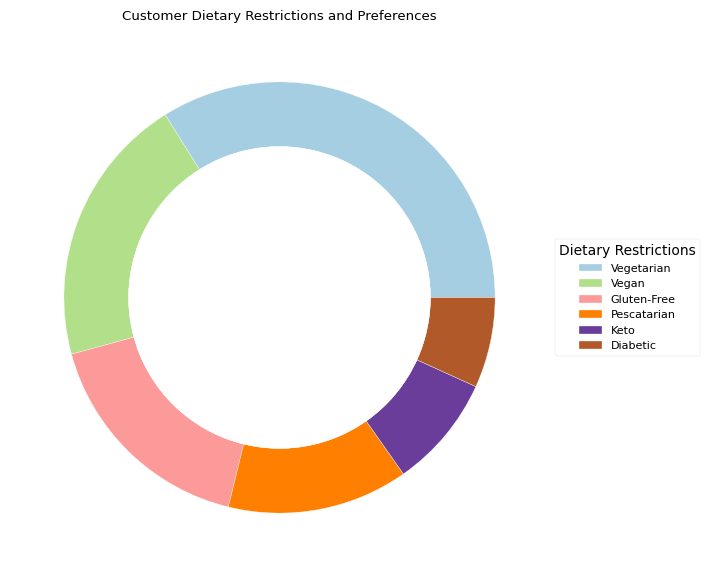Which dietary restriction is the most common among the customers? The most common dietary restriction among customers is represented by the largest segment in the outer ring of the pie chart.
Answer: Vegetarian What is the combined frequency of customers with vegan and gluten-free preferences? To find the combined frequency, sum the individual frequencies of customers who are vegan and gluten-free. Vegan: 12, Gluten-Free: 10, so 12 + 10 = 22
Answer: 22 How does the number of pescatarian customers compare to diabetic customers? To compare these, look at the sizes of their respective segments. For a more accurate comparison, compare their frequencies directly. Pescatarian: 8, Diabetic: 4, so there are twice as many pescatarian customers as diabetic.
Answer: Pescatarian customers are twice as many as diabetic customers Which dietary group has the smallest representation? The smallest segment in the pie chart indicates the dietary group with the smallest representation.
Answer: Diabetic What is the frequency difference between customers with keto and vegetarian preferences? Calculate the difference in frequency between keto and vegetarian customers. Vegetarian: 20, Keto: 5, so 20 - 5 = 15.
Answer: 15 What proportion of the total dietary restriction preferences does the gluten-free category represent? First calculate the total number of dietary restrictions by summing up all frequencies, and then find the proportion of gluten-free preferences. Total = 20 + 12 + 10 + 8 + 5 + 4 = 59. Proportion = (10 / 59) * 100 ≈ 16.95%
Answer: ≈16.95% Which segment has a smaller size visually, pescatarian or keto? Compare the sizes of the segments representing pescatarian and keto in the pie chart. The keto segment appears smaller visually.
Answer: Keto How many more customers have vegetarian preferences compared to those with keto preferences? To find how many more customers have vegetarian preferences compared to keto preferences, subtract the number of keto customers from vegetarian customers. 20 - 5 = 15
Answer: 15 If you combine the frequencies of vegan and keto preferences, does the resulting number surpass the number of vegetarian preferences? Combine the frequencies of vegan and keto, then compare the sum to the vegetarian frequency. Vegan: 12, Keto: 5, so 12 + 5 = 17 which is less than 20.
Answer: No What percentage of the total customers have pescatarian preferences? First, calculate the total number of customers by summing all the frequencies, then find the percentage for pescatarian preferences. Total = 59. Pescatarian = (8 / 59) * 100 ≈ 13.56%.
Answer: ≈13.56% 